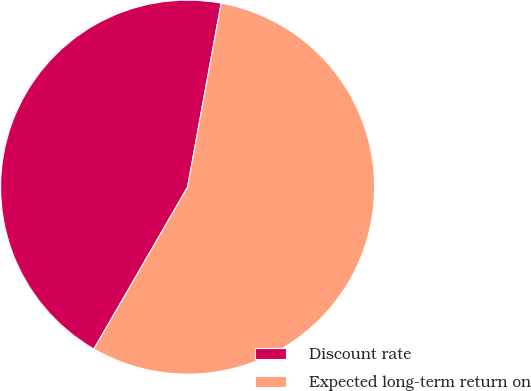Convert chart to OTSL. <chart><loc_0><loc_0><loc_500><loc_500><pie_chart><fcel>Discount rate<fcel>Expected long-term return on<nl><fcel>44.53%<fcel>55.47%<nl></chart> 